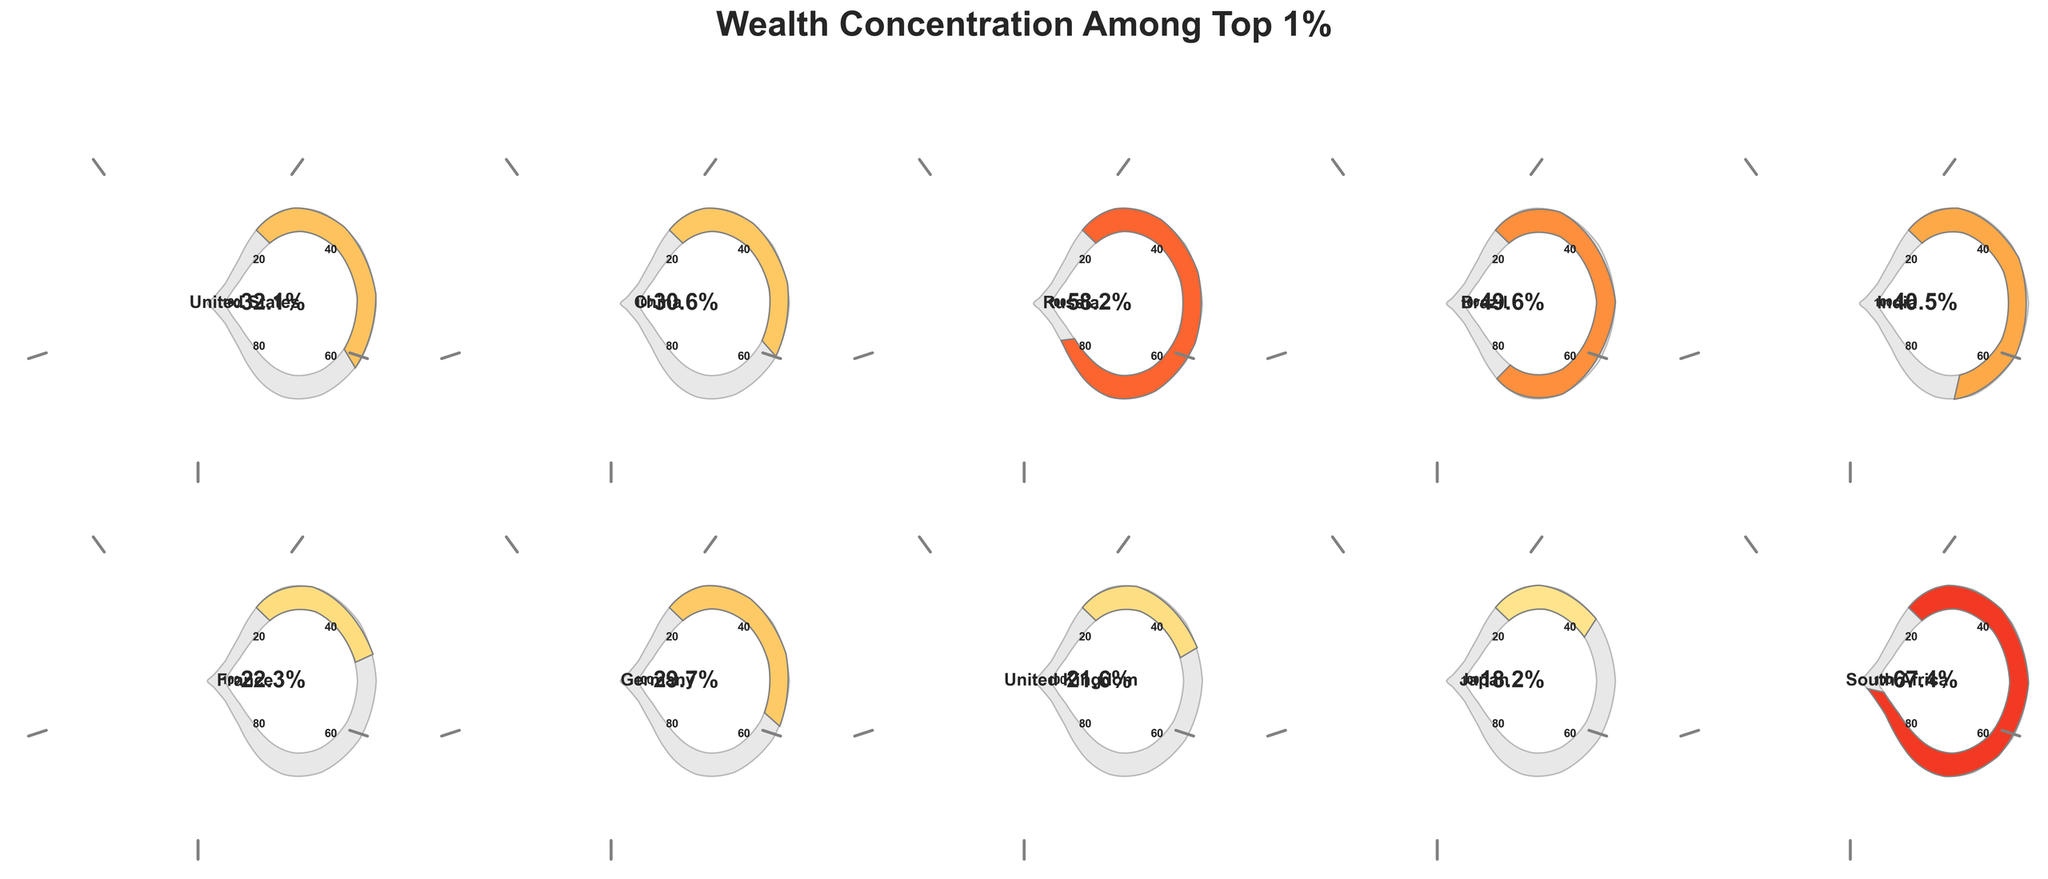How many countries are represented in the figure? Count the number of different gauge charts or the number of country names listed. There are 10 countries (from the data provided).
Answer: 10 What is the wealth concentration percentage among the top 1% in South Africa? Identify the gauge chart labeled "South Africa" and read the percentage shown.
Answer: 67.4% Which country has the lowest wealth concentration among the top 1%? Compare all the values and identify the gauge with the smallest percentage. Japan has the lowest wealth concentration at 18.2%.
Answer: Japan What is the difference in wealth concentration percentage between Brazil and Germany? Subtract the wealth concentration percentage of Germany from that of Brazil: 49.6% (Brazil) - 29.7% (Germany) = 19.9%.
Answer: 19.9% How does the wealth concentration in the United States compare to that in China? Identify and compare the percentages for the United States (32.1%) and China (30.6%). The wealth concentration in the United States is slightly higher than in China.
Answer: United States is higher What is the average wealth concentration percentage among all the countries? Calculate the total sum of all percentages and divide by the number of countries: (32.1 + 30.6 + 58.2 + 49.6 + 40.5 + 22.3 + 29.7 + 21.6 + 18.2 + 67.4) / 10 = 37.0.
Answer: 37.0% Which three countries have wealth concentrations above 50%? Identify and list the countries with percentages above 50: South Africa, Russia, Brazil.
Answer: South Africa, Russia, Brazil What is the median wealth concentration percentage among these countries? List the percentages in ascending order and find the middle value. Ordered: 18.2, 21.6, 22.3, 29.7, 30.6, 32.1, 40.5, 49.6, 58.2, 67.4. The median is (30.6 + 32.1) / 2 = 31.35.
Answer: 31.35 Which countries have wealth concentrations within 5% of 30%? Identify countries with percentages between 25% and 35%: China (30.6%), Germany (29.7%).
Answer: China, Germany What is the combined wealth concentration percentage of the top 1% in France and the United Kingdom? Add the values for France and the United Kingdom: 22.3% + 21.6% = 43.9%.
Answer: 43.9% 